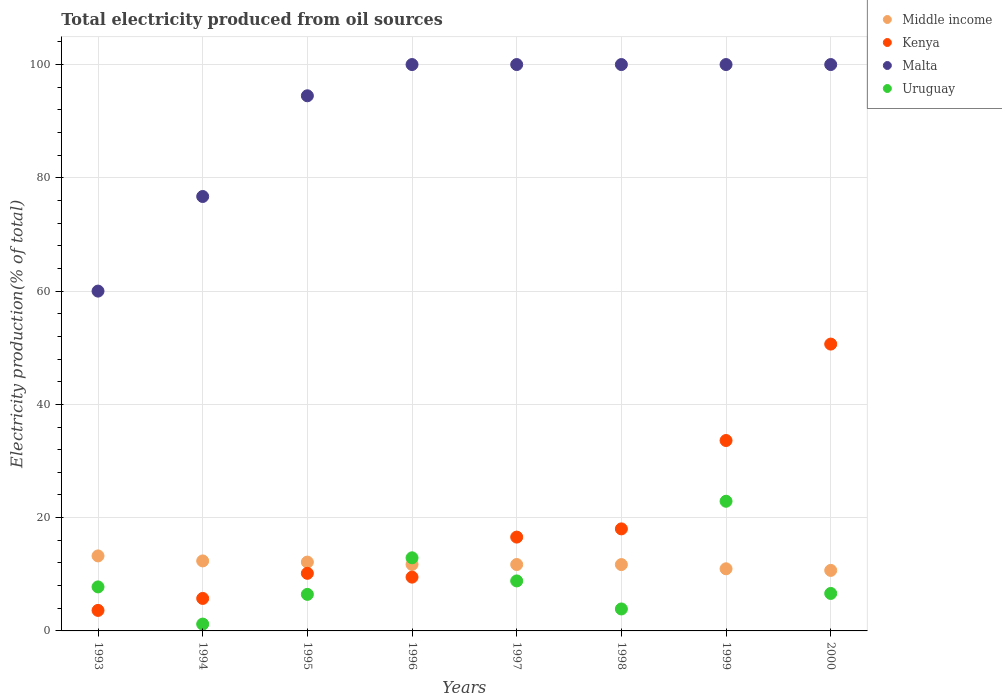How many different coloured dotlines are there?
Offer a very short reply. 4. Is the number of dotlines equal to the number of legend labels?
Offer a terse response. Yes. What is the total electricity produced in Middle income in 2000?
Your answer should be compact. 10.69. Across all years, what is the maximum total electricity produced in Malta?
Make the answer very short. 100. Across all years, what is the minimum total electricity produced in Kenya?
Ensure brevity in your answer.  3.62. In which year was the total electricity produced in Middle income maximum?
Your response must be concise. 1993. What is the total total electricity produced in Malta in the graph?
Make the answer very short. 731.19. What is the difference between the total electricity produced in Middle income in 1993 and that in 1997?
Give a very brief answer. 1.52. What is the difference between the total electricity produced in Malta in 1993 and the total electricity produced in Kenya in 1995?
Make the answer very short. 49.83. What is the average total electricity produced in Malta per year?
Provide a succinct answer. 91.4. In the year 1999, what is the difference between the total electricity produced in Malta and total electricity produced in Middle income?
Your response must be concise. 89.03. In how many years, is the total electricity produced in Uruguay greater than 80 %?
Offer a very short reply. 0. What is the ratio of the total electricity produced in Malta in 1993 to that in 1994?
Your response must be concise. 0.78. What is the difference between the highest and the second highest total electricity produced in Kenya?
Provide a short and direct response. 17.02. What is the difference between the highest and the lowest total electricity produced in Middle income?
Give a very brief answer. 2.56. Is the sum of the total electricity produced in Malta in 1995 and 1999 greater than the maximum total electricity produced in Middle income across all years?
Your answer should be compact. Yes. Is it the case that in every year, the sum of the total electricity produced in Malta and total electricity produced in Middle income  is greater than the sum of total electricity produced in Uruguay and total electricity produced in Kenya?
Your answer should be compact. Yes. Does the total electricity produced in Middle income monotonically increase over the years?
Give a very brief answer. No. Is the total electricity produced in Malta strictly greater than the total electricity produced in Middle income over the years?
Give a very brief answer. Yes. Is the total electricity produced in Uruguay strictly less than the total electricity produced in Middle income over the years?
Keep it short and to the point. No. Are the values on the major ticks of Y-axis written in scientific E-notation?
Give a very brief answer. No. Does the graph contain grids?
Make the answer very short. Yes. What is the title of the graph?
Your answer should be very brief. Total electricity produced from oil sources. Does "Sudan" appear as one of the legend labels in the graph?
Keep it short and to the point. No. What is the label or title of the Y-axis?
Provide a succinct answer. Electricity production(% of total). What is the Electricity production(% of total) in Middle income in 1993?
Provide a succinct answer. 13.24. What is the Electricity production(% of total) of Kenya in 1993?
Offer a terse response. 3.62. What is the Electricity production(% of total) in Uruguay in 1993?
Make the answer very short. 7.77. What is the Electricity production(% of total) of Middle income in 1994?
Your response must be concise. 12.36. What is the Electricity production(% of total) in Kenya in 1994?
Keep it short and to the point. 5.74. What is the Electricity production(% of total) in Malta in 1994?
Ensure brevity in your answer.  76.7. What is the Electricity production(% of total) in Uruguay in 1994?
Make the answer very short. 1.21. What is the Electricity production(% of total) in Middle income in 1995?
Make the answer very short. 12.15. What is the Electricity production(% of total) of Kenya in 1995?
Provide a succinct answer. 10.17. What is the Electricity production(% of total) of Malta in 1995?
Provide a succinct answer. 94.49. What is the Electricity production(% of total) in Uruguay in 1995?
Your answer should be very brief. 6.45. What is the Electricity production(% of total) of Middle income in 1996?
Offer a very short reply. 11.74. What is the Electricity production(% of total) in Kenya in 1996?
Give a very brief answer. 9.5. What is the Electricity production(% of total) of Malta in 1996?
Your response must be concise. 100. What is the Electricity production(% of total) in Uruguay in 1996?
Provide a succinct answer. 12.91. What is the Electricity production(% of total) in Middle income in 1997?
Keep it short and to the point. 11.73. What is the Electricity production(% of total) of Kenya in 1997?
Make the answer very short. 16.57. What is the Electricity production(% of total) of Malta in 1997?
Give a very brief answer. 100. What is the Electricity production(% of total) of Uruguay in 1997?
Ensure brevity in your answer.  8.83. What is the Electricity production(% of total) in Middle income in 1998?
Provide a succinct answer. 11.71. What is the Electricity production(% of total) of Kenya in 1998?
Give a very brief answer. 18.02. What is the Electricity production(% of total) in Uruguay in 1998?
Provide a short and direct response. 3.88. What is the Electricity production(% of total) in Middle income in 1999?
Keep it short and to the point. 10.97. What is the Electricity production(% of total) of Kenya in 1999?
Your answer should be very brief. 33.62. What is the Electricity production(% of total) in Malta in 1999?
Offer a terse response. 100. What is the Electricity production(% of total) of Uruguay in 1999?
Your answer should be very brief. 22.89. What is the Electricity production(% of total) of Middle income in 2000?
Your answer should be very brief. 10.69. What is the Electricity production(% of total) of Kenya in 2000?
Offer a terse response. 50.64. What is the Electricity production(% of total) of Uruguay in 2000?
Provide a succinct answer. 6.62. Across all years, what is the maximum Electricity production(% of total) of Middle income?
Your answer should be very brief. 13.24. Across all years, what is the maximum Electricity production(% of total) in Kenya?
Offer a terse response. 50.64. Across all years, what is the maximum Electricity production(% of total) of Uruguay?
Your answer should be compact. 22.89. Across all years, what is the minimum Electricity production(% of total) of Middle income?
Your answer should be very brief. 10.69. Across all years, what is the minimum Electricity production(% of total) of Kenya?
Provide a succinct answer. 3.62. Across all years, what is the minimum Electricity production(% of total) in Uruguay?
Provide a succinct answer. 1.21. What is the total Electricity production(% of total) in Middle income in the graph?
Give a very brief answer. 94.59. What is the total Electricity production(% of total) in Kenya in the graph?
Make the answer very short. 147.87. What is the total Electricity production(% of total) of Malta in the graph?
Your answer should be compact. 731.19. What is the total Electricity production(% of total) in Uruguay in the graph?
Offer a very short reply. 70.56. What is the difference between the Electricity production(% of total) of Middle income in 1993 and that in 1994?
Provide a succinct answer. 0.88. What is the difference between the Electricity production(% of total) in Kenya in 1993 and that in 1994?
Give a very brief answer. -2.11. What is the difference between the Electricity production(% of total) in Malta in 1993 and that in 1994?
Ensure brevity in your answer.  -16.7. What is the difference between the Electricity production(% of total) of Uruguay in 1993 and that in 1994?
Provide a short and direct response. 6.56. What is the difference between the Electricity production(% of total) of Middle income in 1993 and that in 1995?
Make the answer very short. 1.09. What is the difference between the Electricity production(% of total) of Kenya in 1993 and that in 1995?
Ensure brevity in your answer.  -6.55. What is the difference between the Electricity production(% of total) in Malta in 1993 and that in 1995?
Provide a short and direct response. -34.49. What is the difference between the Electricity production(% of total) in Uruguay in 1993 and that in 1995?
Ensure brevity in your answer.  1.32. What is the difference between the Electricity production(% of total) of Middle income in 1993 and that in 1996?
Your answer should be compact. 1.51. What is the difference between the Electricity production(% of total) in Kenya in 1993 and that in 1996?
Offer a very short reply. -5.87. What is the difference between the Electricity production(% of total) of Malta in 1993 and that in 1996?
Ensure brevity in your answer.  -40. What is the difference between the Electricity production(% of total) in Uruguay in 1993 and that in 1996?
Offer a terse response. -5.14. What is the difference between the Electricity production(% of total) of Middle income in 1993 and that in 1997?
Keep it short and to the point. 1.52. What is the difference between the Electricity production(% of total) of Kenya in 1993 and that in 1997?
Your answer should be compact. -12.94. What is the difference between the Electricity production(% of total) in Malta in 1993 and that in 1997?
Your answer should be compact. -40. What is the difference between the Electricity production(% of total) of Uruguay in 1993 and that in 1997?
Offer a very short reply. -1.06. What is the difference between the Electricity production(% of total) in Middle income in 1993 and that in 1998?
Offer a terse response. 1.53. What is the difference between the Electricity production(% of total) in Kenya in 1993 and that in 1998?
Offer a very short reply. -14.39. What is the difference between the Electricity production(% of total) of Uruguay in 1993 and that in 1998?
Provide a short and direct response. 3.89. What is the difference between the Electricity production(% of total) in Middle income in 1993 and that in 1999?
Give a very brief answer. 2.27. What is the difference between the Electricity production(% of total) of Kenya in 1993 and that in 1999?
Keep it short and to the point. -30. What is the difference between the Electricity production(% of total) in Uruguay in 1993 and that in 1999?
Your answer should be very brief. -15.12. What is the difference between the Electricity production(% of total) of Middle income in 1993 and that in 2000?
Provide a short and direct response. 2.56. What is the difference between the Electricity production(% of total) of Kenya in 1993 and that in 2000?
Offer a very short reply. -47.02. What is the difference between the Electricity production(% of total) in Uruguay in 1993 and that in 2000?
Make the answer very short. 1.16. What is the difference between the Electricity production(% of total) of Middle income in 1994 and that in 1995?
Give a very brief answer. 0.21. What is the difference between the Electricity production(% of total) of Kenya in 1994 and that in 1995?
Offer a terse response. -4.43. What is the difference between the Electricity production(% of total) in Malta in 1994 and that in 1995?
Your response must be concise. -17.78. What is the difference between the Electricity production(% of total) of Uruguay in 1994 and that in 1995?
Give a very brief answer. -5.25. What is the difference between the Electricity production(% of total) of Middle income in 1994 and that in 1996?
Offer a very short reply. 0.62. What is the difference between the Electricity production(% of total) of Kenya in 1994 and that in 1996?
Your answer should be very brief. -3.76. What is the difference between the Electricity production(% of total) in Malta in 1994 and that in 1996?
Offer a very short reply. -23.3. What is the difference between the Electricity production(% of total) in Uruguay in 1994 and that in 1996?
Provide a succinct answer. -11.7. What is the difference between the Electricity production(% of total) of Middle income in 1994 and that in 1997?
Provide a succinct answer. 0.63. What is the difference between the Electricity production(% of total) in Kenya in 1994 and that in 1997?
Ensure brevity in your answer.  -10.83. What is the difference between the Electricity production(% of total) of Malta in 1994 and that in 1997?
Ensure brevity in your answer.  -23.3. What is the difference between the Electricity production(% of total) in Uruguay in 1994 and that in 1997?
Provide a succinct answer. -7.62. What is the difference between the Electricity production(% of total) of Middle income in 1994 and that in 1998?
Give a very brief answer. 0.65. What is the difference between the Electricity production(% of total) in Kenya in 1994 and that in 1998?
Offer a terse response. -12.28. What is the difference between the Electricity production(% of total) in Malta in 1994 and that in 1998?
Offer a very short reply. -23.3. What is the difference between the Electricity production(% of total) of Uruguay in 1994 and that in 1998?
Give a very brief answer. -2.67. What is the difference between the Electricity production(% of total) of Middle income in 1994 and that in 1999?
Your answer should be very brief. 1.39. What is the difference between the Electricity production(% of total) of Kenya in 1994 and that in 1999?
Keep it short and to the point. -27.88. What is the difference between the Electricity production(% of total) in Malta in 1994 and that in 1999?
Your answer should be very brief. -23.3. What is the difference between the Electricity production(% of total) of Uruguay in 1994 and that in 1999?
Your response must be concise. -21.69. What is the difference between the Electricity production(% of total) in Middle income in 1994 and that in 2000?
Offer a very short reply. 1.67. What is the difference between the Electricity production(% of total) of Kenya in 1994 and that in 2000?
Your answer should be very brief. -44.91. What is the difference between the Electricity production(% of total) of Malta in 1994 and that in 2000?
Offer a very short reply. -23.3. What is the difference between the Electricity production(% of total) in Uruguay in 1994 and that in 2000?
Offer a terse response. -5.41. What is the difference between the Electricity production(% of total) of Middle income in 1995 and that in 1996?
Your answer should be compact. 0.42. What is the difference between the Electricity production(% of total) of Kenya in 1995 and that in 1996?
Your answer should be compact. 0.67. What is the difference between the Electricity production(% of total) in Malta in 1995 and that in 1996?
Provide a succinct answer. -5.51. What is the difference between the Electricity production(% of total) in Uruguay in 1995 and that in 1996?
Give a very brief answer. -6.46. What is the difference between the Electricity production(% of total) in Middle income in 1995 and that in 1997?
Give a very brief answer. 0.43. What is the difference between the Electricity production(% of total) of Kenya in 1995 and that in 1997?
Provide a succinct answer. -6.4. What is the difference between the Electricity production(% of total) of Malta in 1995 and that in 1997?
Provide a short and direct response. -5.51. What is the difference between the Electricity production(% of total) of Uruguay in 1995 and that in 1997?
Ensure brevity in your answer.  -2.37. What is the difference between the Electricity production(% of total) of Middle income in 1995 and that in 1998?
Your answer should be compact. 0.44. What is the difference between the Electricity production(% of total) in Kenya in 1995 and that in 1998?
Your answer should be very brief. -7.85. What is the difference between the Electricity production(% of total) in Malta in 1995 and that in 1998?
Ensure brevity in your answer.  -5.51. What is the difference between the Electricity production(% of total) of Uruguay in 1995 and that in 1998?
Keep it short and to the point. 2.58. What is the difference between the Electricity production(% of total) of Middle income in 1995 and that in 1999?
Offer a terse response. 1.18. What is the difference between the Electricity production(% of total) of Kenya in 1995 and that in 1999?
Your answer should be compact. -23.45. What is the difference between the Electricity production(% of total) in Malta in 1995 and that in 1999?
Your answer should be compact. -5.51. What is the difference between the Electricity production(% of total) in Uruguay in 1995 and that in 1999?
Offer a very short reply. -16.44. What is the difference between the Electricity production(% of total) in Middle income in 1995 and that in 2000?
Provide a succinct answer. 1.47. What is the difference between the Electricity production(% of total) in Kenya in 1995 and that in 2000?
Your answer should be very brief. -40.48. What is the difference between the Electricity production(% of total) of Malta in 1995 and that in 2000?
Provide a succinct answer. -5.51. What is the difference between the Electricity production(% of total) in Uruguay in 1995 and that in 2000?
Provide a short and direct response. -0.16. What is the difference between the Electricity production(% of total) of Middle income in 1996 and that in 1997?
Make the answer very short. 0.01. What is the difference between the Electricity production(% of total) of Kenya in 1996 and that in 1997?
Your answer should be very brief. -7.07. What is the difference between the Electricity production(% of total) of Uruguay in 1996 and that in 1997?
Offer a terse response. 4.08. What is the difference between the Electricity production(% of total) of Middle income in 1996 and that in 1998?
Provide a succinct answer. 0.02. What is the difference between the Electricity production(% of total) in Kenya in 1996 and that in 1998?
Offer a very short reply. -8.52. What is the difference between the Electricity production(% of total) in Malta in 1996 and that in 1998?
Provide a short and direct response. 0. What is the difference between the Electricity production(% of total) in Uruguay in 1996 and that in 1998?
Your answer should be compact. 9.03. What is the difference between the Electricity production(% of total) of Middle income in 1996 and that in 1999?
Make the answer very short. 0.76. What is the difference between the Electricity production(% of total) of Kenya in 1996 and that in 1999?
Provide a short and direct response. -24.12. What is the difference between the Electricity production(% of total) in Uruguay in 1996 and that in 1999?
Offer a very short reply. -9.99. What is the difference between the Electricity production(% of total) in Middle income in 1996 and that in 2000?
Give a very brief answer. 1.05. What is the difference between the Electricity production(% of total) in Kenya in 1996 and that in 2000?
Keep it short and to the point. -41.15. What is the difference between the Electricity production(% of total) of Malta in 1996 and that in 2000?
Your response must be concise. 0. What is the difference between the Electricity production(% of total) of Uruguay in 1996 and that in 2000?
Your answer should be very brief. 6.29. What is the difference between the Electricity production(% of total) of Middle income in 1997 and that in 1998?
Offer a terse response. 0.01. What is the difference between the Electricity production(% of total) in Kenya in 1997 and that in 1998?
Offer a very short reply. -1.45. What is the difference between the Electricity production(% of total) in Uruguay in 1997 and that in 1998?
Your response must be concise. 4.95. What is the difference between the Electricity production(% of total) in Middle income in 1997 and that in 1999?
Make the answer very short. 0.75. What is the difference between the Electricity production(% of total) of Kenya in 1997 and that in 1999?
Your answer should be compact. -17.05. What is the difference between the Electricity production(% of total) in Malta in 1997 and that in 1999?
Your answer should be compact. 0. What is the difference between the Electricity production(% of total) in Uruguay in 1997 and that in 1999?
Ensure brevity in your answer.  -14.07. What is the difference between the Electricity production(% of total) in Middle income in 1997 and that in 2000?
Offer a terse response. 1.04. What is the difference between the Electricity production(% of total) in Kenya in 1997 and that in 2000?
Provide a succinct answer. -34.08. What is the difference between the Electricity production(% of total) of Malta in 1997 and that in 2000?
Your response must be concise. 0. What is the difference between the Electricity production(% of total) in Uruguay in 1997 and that in 2000?
Ensure brevity in your answer.  2.21. What is the difference between the Electricity production(% of total) in Middle income in 1998 and that in 1999?
Your answer should be compact. 0.74. What is the difference between the Electricity production(% of total) of Kenya in 1998 and that in 1999?
Make the answer very short. -15.6. What is the difference between the Electricity production(% of total) of Malta in 1998 and that in 1999?
Your answer should be very brief. 0. What is the difference between the Electricity production(% of total) of Uruguay in 1998 and that in 1999?
Make the answer very short. -19.02. What is the difference between the Electricity production(% of total) of Middle income in 1998 and that in 2000?
Give a very brief answer. 1.03. What is the difference between the Electricity production(% of total) of Kenya in 1998 and that in 2000?
Offer a very short reply. -32.63. What is the difference between the Electricity production(% of total) of Uruguay in 1998 and that in 2000?
Your answer should be compact. -2.74. What is the difference between the Electricity production(% of total) of Middle income in 1999 and that in 2000?
Give a very brief answer. 0.28. What is the difference between the Electricity production(% of total) in Kenya in 1999 and that in 2000?
Give a very brief answer. -17.02. What is the difference between the Electricity production(% of total) of Malta in 1999 and that in 2000?
Your answer should be compact. 0. What is the difference between the Electricity production(% of total) in Uruguay in 1999 and that in 2000?
Make the answer very short. 16.28. What is the difference between the Electricity production(% of total) of Middle income in 1993 and the Electricity production(% of total) of Kenya in 1994?
Keep it short and to the point. 7.51. What is the difference between the Electricity production(% of total) of Middle income in 1993 and the Electricity production(% of total) of Malta in 1994?
Offer a very short reply. -63.46. What is the difference between the Electricity production(% of total) of Middle income in 1993 and the Electricity production(% of total) of Uruguay in 1994?
Ensure brevity in your answer.  12.04. What is the difference between the Electricity production(% of total) in Kenya in 1993 and the Electricity production(% of total) in Malta in 1994?
Your answer should be very brief. -73.08. What is the difference between the Electricity production(% of total) of Kenya in 1993 and the Electricity production(% of total) of Uruguay in 1994?
Offer a terse response. 2.42. What is the difference between the Electricity production(% of total) of Malta in 1993 and the Electricity production(% of total) of Uruguay in 1994?
Ensure brevity in your answer.  58.79. What is the difference between the Electricity production(% of total) of Middle income in 1993 and the Electricity production(% of total) of Kenya in 1995?
Keep it short and to the point. 3.08. What is the difference between the Electricity production(% of total) in Middle income in 1993 and the Electricity production(% of total) in Malta in 1995?
Offer a very short reply. -81.24. What is the difference between the Electricity production(% of total) in Middle income in 1993 and the Electricity production(% of total) in Uruguay in 1995?
Provide a short and direct response. 6.79. What is the difference between the Electricity production(% of total) of Kenya in 1993 and the Electricity production(% of total) of Malta in 1995?
Make the answer very short. -90.86. What is the difference between the Electricity production(% of total) in Kenya in 1993 and the Electricity production(% of total) in Uruguay in 1995?
Your answer should be compact. -2.83. What is the difference between the Electricity production(% of total) of Malta in 1993 and the Electricity production(% of total) of Uruguay in 1995?
Offer a very short reply. 53.55. What is the difference between the Electricity production(% of total) of Middle income in 1993 and the Electricity production(% of total) of Kenya in 1996?
Your answer should be compact. 3.75. What is the difference between the Electricity production(% of total) in Middle income in 1993 and the Electricity production(% of total) in Malta in 1996?
Make the answer very short. -86.76. What is the difference between the Electricity production(% of total) in Middle income in 1993 and the Electricity production(% of total) in Uruguay in 1996?
Provide a succinct answer. 0.34. What is the difference between the Electricity production(% of total) of Kenya in 1993 and the Electricity production(% of total) of Malta in 1996?
Provide a succinct answer. -96.38. What is the difference between the Electricity production(% of total) in Kenya in 1993 and the Electricity production(% of total) in Uruguay in 1996?
Make the answer very short. -9.29. What is the difference between the Electricity production(% of total) in Malta in 1993 and the Electricity production(% of total) in Uruguay in 1996?
Provide a succinct answer. 47.09. What is the difference between the Electricity production(% of total) in Middle income in 1993 and the Electricity production(% of total) in Kenya in 1997?
Offer a terse response. -3.32. What is the difference between the Electricity production(% of total) in Middle income in 1993 and the Electricity production(% of total) in Malta in 1997?
Your answer should be very brief. -86.76. What is the difference between the Electricity production(% of total) of Middle income in 1993 and the Electricity production(% of total) of Uruguay in 1997?
Keep it short and to the point. 4.42. What is the difference between the Electricity production(% of total) of Kenya in 1993 and the Electricity production(% of total) of Malta in 1997?
Your answer should be very brief. -96.38. What is the difference between the Electricity production(% of total) of Kenya in 1993 and the Electricity production(% of total) of Uruguay in 1997?
Ensure brevity in your answer.  -5.2. What is the difference between the Electricity production(% of total) of Malta in 1993 and the Electricity production(% of total) of Uruguay in 1997?
Your answer should be very brief. 51.17. What is the difference between the Electricity production(% of total) in Middle income in 1993 and the Electricity production(% of total) in Kenya in 1998?
Your answer should be compact. -4.77. What is the difference between the Electricity production(% of total) in Middle income in 1993 and the Electricity production(% of total) in Malta in 1998?
Provide a succinct answer. -86.76. What is the difference between the Electricity production(% of total) in Middle income in 1993 and the Electricity production(% of total) in Uruguay in 1998?
Offer a very short reply. 9.37. What is the difference between the Electricity production(% of total) of Kenya in 1993 and the Electricity production(% of total) of Malta in 1998?
Provide a short and direct response. -96.38. What is the difference between the Electricity production(% of total) of Kenya in 1993 and the Electricity production(% of total) of Uruguay in 1998?
Make the answer very short. -0.25. What is the difference between the Electricity production(% of total) in Malta in 1993 and the Electricity production(% of total) in Uruguay in 1998?
Give a very brief answer. 56.12. What is the difference between the Electricity production(% of total) of Middle income in 1993 and the Electricity production(% of total) of Kenya in 1999?
Your answer should be compact. -20.38. What is the difference between the Electricity production(% of total) in Middle income in 1993 and the Electricity production(% of total) in Malta in 1999?
Offer a terse response. -86.76. What is the difference between the Electricity production(% of total) of Middle income in 1993 and the Electricity production(% of total) of Uruguay in 1999?
Ensure brevity in your answer.  -9.65. What is the difference between the Electricity production(% of total) of Kenya in 1993 and the Electricity production(% of total) of Malta in 1999?
Make the answer very short. -96.38. What is the difference between the Electricity production(% of total) in Kenya in 1993 and the Electricity production(% of total) in Uruguay in 1999?
Ensure brevity in your answer.  -19.27. What is the difference between the Electricity production(% of total) of Malta in 1993 and the Electricity production(% of total) of Uruguay in 1999?
Ensure brevity in your answer.  37.11. What is the difference between the Electricity production(% of total) of Middle income in 1993 and the Electricity production(% of total) of Kenya in 2000?
Ensure brevity in your answer.  -37.4. What is the difference between the Electricity production(% of total) in Middle income in 1993 and the Electricity production(% of total) in Malta in 2000?
Your answer should be very brief. -86.76. What is the difference between the Electricity production(% of total) in Middle income in 1993 and the Electricity production(% of total) in Uruguay in 2000?
Your answer should be compact. 6.63. What is the difference between the Electricity production(% of total) of Kenya in 1993 and the Electricity production(% of total) of Malta in 2000?
Offer a terse response. -96.38. What is the difference between the Electricity production(% of total) of Kenya in 1993 and the Electricity production(% of total) of Uruguay in 2000?
Provide a succinct answer. -2.99. What is the difference between the Electricity production(% of total) in Malta in 1993 and the Electricity production(% of total) in Uruguay in 2000?
Your answer should be compact. 53.38. What is the difference between the Electricity production(% of total) of Middle income in 1994 and the Electricity production(% of total) of Kenya in 1995?
Provide a succinct answer. 2.19. What is the difference between the Electricity production(% of total) of Middle income in 1994 and the Electricity production(% of total) of Malta in 1995?
Provide a succinct answer. -82.13. What is the difference between the Electricity production(% of total) in Middle income in 1994 and the Electricity production(% of total) in Uruguay in 1995?
Your response must be concise. 5.91. What is the difference between the Electricity production(% of total) in Kenya in 1994 and the Electricity production(% of total) in Malta in 1995?
Your response must be concise. -88.75. What is the difference between the Electricity production(% of total) of Kenya in 1994 and the Electricity production(% of total) of Uruguay in 1995?
Make the answer very short. -0.72. What is the difference between the Electricity production(% of total) in Malta in 1994 and the Electricity production(% of total) in Uruguay in 1995?
Ensure brevity in your answer.  70.25. What is the difference between the Electricity production(% of total) of Middle income in 1994 and the Electricity production(% of total) of Kenya in 1996?
Give a very brief answer. 2.86. What is the difference between the Electricity production(% of total) in Middle income in 1994 and the Electricity production(% of total) in Malta in 1996?
Offer a terse response. -87.64. What is the difference between the Electricity production(% of total) in Middle income in 1994 and the Electricity production(% of total) in Uruguay in 1996?
Keep it short and to the point. -0.55. What is the difference between the Electricity production(% of total) of Kenya in 1994 and the Electricity production(% of total) of Malta in 1996?
Provide a succinct answer. -94.26. What is the difference between the Electricity production(% of total) in Kenya in 1994 and the Electricity production(% of total) in Uruguay in 1996?
Make the answer very short. -7.17. What is the difference between the Electricity production(% of total) in Malta in 1994 and the Electricity production(% of total) in Uruguay in 1996?
Your answer should be compact. 63.79. What is the difference between the Electricity production(% of total) of Middle income in 1994 and the Electricity production(% of total) of Kenya in 1997?
Offer a terse response. -4.21. What is the difference between the Electricity production(% of total) in Middle income in 1994 and the Electricity production(% of total) in Malta in 1997?
Provide a short and direct response. -87.64. What is the difference between the Electricity production(% of total) of Middle income in 1994 and the Electricity production(% of total) of Uruguay in 1997?
Offer a terse response. 3.53. What is the difference between the Electricity production(% of total) in Kenya in 1994 and the Electricity production(% of total) in Malta in 1997?
Your answer should be compact. -94.26. What is the difference between the Electricity production(% of total) of Kenya in 1994 and the Electricity production(% of total) of Uruguay in 1997?
Offer a terse response. -3.09. What is the difference between the Electricity production(% of total) in Malta in 1994 and the Electricity production(% of total) in Uruguay in 1997?
Make the answer very short. 67.88. What is the difference between the Electricity production(% of total) in Middle income in 1994 and the Electricity production(% of total) in Kenya in 1998?
Give a very brief answer. -5.66. What is the difference between the Electricity production(% of total) in Middle income in 1994 and the Electricity production(% of total) in Malta in 1998?
Offer a terse response. -87.64. What is the difference between the Electricity production(% of total) in Middle income in 1994 and the Electricity production(% of total) in Uruguay in 1998?
Make the answer very short. 8.48. What is the difference between the Electricity production(% of total) in Kenya in 1994 and the Electricity production(% of total) in Malta in 1998?
Provide a short and direct response. -94.26. What is the difference between the Electricity production(% of total) in Kenya in 1994 and the Electricity production(% of total) in Uruguay in 1998?
Provide a short and direct response. 1.86. What is the difference between the Electricity production(% of total) in Malta in 1994 and the Electricity production(% of total) in Uruguay in 1998?
Your response must be concise. 72.83. What is the difference between the Electricity production(% of total) of Middle income in 1994 and the Electricity production(% of total) of Kenya in 1999?
Provide a short and direct response. -21.26. What is the difference between the Electricity production(% of total) of Middle income in 1994 and the Electricity production(% of total) of Malta in 1999?
Give a very brief answer. -87.64. What is the difference between the Electricity production(% of total) of Middle income in 1994 and the Electricity production(% of total) of Uruguay in 1999?
Your answer should be compact. -10.53. What is the difference between the Electricity production(% of total) in Kenya in 1994 and the Electricity production(% of total) in Malta in 1999?
Provide a short and direct response. -94.26. What is the difference between the Electricity production(% of total) in Kenya in 1994 and the Electricity production(% of total) in Uruguay in 1999?
Offer a terse response. -17.16. What is the difference between the Electricity production(% of total) of Malta in 1994 and the Electricity production(% of total) of Uruguay in 1999?
Provide a succinct answer. 53.81. What is the difference between the Electricity production(% of total) of Middle income in 1994 and the Electricity production(% of total) of Kenya in 2000?
Your response must be concise. -38.28. What is the difference between the Electricity production(% of total) in Middle income in 1994 and the Electricity production(% of total) in Malta in 2000?
Offer a very short reply. -87.64. What is the difference between the Electricity production(% of total) in Middle income in 1994 and the Electricity production(% of total) in Uruguay in 2000?
Keep it short and to the point. 5.74. What is the difference between the Electricity production(% of total) in Kenya in 1994 and the Electricity production(% of total) in Malta in 2000?
Your response must be concise. -94.26. What is the difference between the Electricity production(% of total) of Kenya in 1994 and the Electricity production(% of total) of Uruguay in 2000?
Give a very brief answer. -0.88. What is the difference between the Electricity production(% of total) of Malta in 1994 and the Electricity production(% of total) of Uruguay in 2000?
Your answer should be compact. 70.09. What is the difference between the Electricity production(% of total) of Middle income in 1995 and the Electricity production(% of total) of Kenya in 1996?
Keep it short and to the point. 2.66. What is the difference between the Electricity production(% of total) in Middle income in 1995 and the Electricity production(% of total) in Malta in 1996?
Your answer should be very brief. -87.85. What is the difference between the Electricity production(% of total) in Middle income in 1995 and the Electricity production(% of total) in Uruguay in 1996?
Keep it short and to the point. -0.75. What is the difference between the Electricity production(% of total) in Kenya in 1995 and the Electricity production(% of total) in Malta in 1996?
Keep it short and to the point. -89.83. What is the difference between the Electricity production(% of total) of Kenya in 1995 and the Electricity production(% of total) of Uruguay in 1996?
Give a very brief answer. -2.74. What is the difference between the Electricity production(% of total) of Malta in 1995 and the Electricity production(% of total) of Uruguay in 1996?
Provide a succinct answer. 81.58. What is the difference between the Electricity production(% of total) of Middle income in 1995 and the Electricity production(% of total) of Kenya in 1997?
Give a very brief answer. -4.41. What is the difference between the Electricity production(% of total) in Middle income in 1995 and the Electricity production(% of total) in Malta in 1997?
Give a very brief answer. -87.85. What is the difference between the Electricity production(% of total) in Middle income in 1995 and the Electricity production(% of total) in Uruguay in 1997?
Your answer should be very brief. 3.33. What is the difference between the Electricity production(% of total) in Kenya in 1995 and the Electricity production(% of total) in Malta in 1997?
Provide a short and direct response. -89.83. What is the difference between the Electricity production(% of total) in Kenya in 1995 and the Electricity production(% of total) in Uruguay in 1997?
Give a very brief answer. 1.34. What is the difference between the Electricity production(% of total) in Malta in 1995 and the Electricity production(% of total) in Uruguay in 1997?
Offer a very short reply. 85.66. What is the difference between the Electricity production(% of total) of Middle income in 1995 and the Electricity production(% of total) of Kenya in 1998?
Your answer should be compact. -5.86. What is the difference between the Electricity production(% of total) of Middle income in 1995 and the Electricity production(% of total) of Malta in 1998?
Make the answer very short. -87.85. What is the difference between the Electricity production(% of total) of Middle income in 1995 and the Electricity production(% of total) of Uruguay in 1998?
Make the answer very short. 8.28. What is the difference between the Electricity production(% of total) in Kenya in 1995 and the Electricity production(% of total) in Malta in 1998?
Keep it short and to the point. -89.83. What is the difference between the Electricity production(% of total) in Kenya in 1995 and the Electricity production(% of total) in Uruguay in 1998?
Keep it short and to the point. 6.29. What is the difference between the Electricity production(% of total) of Malta in 1995 and the Electricity production(% of total) of Uruguay in 1998?
Ensure brevity in your answer.  90.61. What is the difference between the Electricity production(% of total) in Middle income in 1995 and the Electricity production(% of total) in Kenya in 1999?
Your answer should be compact. -21.47. What is the difference between the Electricity production(% of total) of Middle income in 1995 and the Electricity production(% of total) of Malta in 1999?
Provide a short and direct response. -87.85. What is the difference between the Electricity production(% of total) in Middle income in 1995 and the Electricity production(% of total) in Uruguay in 1999?
Make the answer very short. -10.74. What is the difference between the Electricity production(% of total) in Kenya in 1995 and the Electricity production(% of total) in Malta in 1999?
Give a very brief answer. -89.83. What is the difference between the Electricity production(% of total) in Kenya in 1995 and the Electricity production(% of total) in Uruguay in 1999?
Make the answer very short. -12.73. What is the difference between the Electricity production(% of total) in Malta in 1995 and the Electricity production(% of total) in Uruguay in 1999?
Your answer should be compact. 71.59. What is the difference between the Electricity production(% of total) of Middle income in 1995 and the Electricity production(% of total) of Kenya in 2000?
Ensure brevity in your answer.  -38.49. What is the difference between the Electricity production(% of total) of Middle income in 1995 and the Electricity production(% of total) of Malta in 2000?
Your response must be concise. -87.85. What is the difference between the Electricity production(% of total) of Middle income in 1995 and the Electricity production(% of total) of Uruguay in 2000?
Make the answer very short. 5.54. What is the difference between the Electricity production(% of total) in Kenya in 1995 and the Electricity production(% of total) in Malta in 2000?
Provide a short and direct response. -89.83. What is the difference between the Electricity production(% of total) of Kenya in 1995 and the Electricity production(% of total) of Uruguay in 2000?
Your answer should be compact. 3.55. What is the difference between the Electricity production(% of total) in Malta in 1995 and the Electricity production(% of total) in Uruguay in 2000?
Your answer should be compact. 87.87. What is the difference between the Electricity production(% of total) of Middle income in 1996 and the Electricity production(% of total) of Kenya in 1997?
Your response must be concise. -4.83. What is the difference between the Electricity production(% of total) in Middle income in 1996 and the Electricity production(% of total) in Malta in 1997?
Your answer should be very brief. -88.26. What is the difference between the Electricity production(% of total) of Middle income in 1996 and the Electricity production(% of total) of Uruguay in 1997?
Provide a succinct answer. 2.91. What is the difference between the Electricity production(% of total) of Kenya in 1996 and the Electricity production(% of total) of Malta in 1997?
Give a very brief answer. -90.5. What is the difference between the Electricity production(% of total) in Kenya in 1996 and the Electricity production(% of total) in Uruguay in 1997?
Your answer should be very brief. 0.67. What is the difference between the Electricity production(% of total) in Malta in 1996 and the Electricity production(% of total) in Uruguay in 1997?
Keep it short and to the point. 91.17. What is the difference between the Electricity production(% of total) of Middle income in 1996 and the Electricity production(% of total) of Kenya in 1998?
Ensure brevity in your answer.  -6.28. What is the difference between the Electricity production(% of total) of Middle income in 1996 and the Electricity production(% of total) of Malta in 1998?
Your response must be concise. -88.26. What is the difference between the Electricity production(% of total) in Middle income in 1996 and the Electricity production(% of total) in Uruguay in 1998?
Your response must be concise. 7.86. What is the difference between the Electricity production(% of total) of Kenya in 1996 and the Electricity production(% of total) of Malta in 1998?
Ensure brevity in your answer.  -90.5. What is the difference between the Electricity production(% of total) in Kenya in 1996 and the Electricity production(% of total) in Uruguay in 1998?
Your answer should be very brief. 5.62. What is the difference between the Electricity production(% of total) in Malta in 1996 and the Electricity production(% of total) in Uruguay in 1998?
Give a very brief answer. 96.12. What is the difference between the Electricity production(% of total) of Middle income in 1996 and the Electricity production(% of total) of Kenya in 1999?
Your answer should be very brief. -21.88. What is the difference between the Electricity production(% of total) of Middle income in 1996 and the Electricity production(% of total) of Malta in 1999?
Give a very brief answer. -88.26. What is the difference between the Electricity production(% of total) of Middle income in 1996 and the Electricity production(% of total) of Uruguay in 1999?
Give a very brief answer. -11.16. What is the difference between the Electricity production(% of total) of Kenya in 1996 and the Electricity production(% of total) of Malta in 1999?
Your answer should be compact. -90.5. What is the difference between the Electricity production(% of total) in Kenya in 1996 and the Electricity production(% of total) in Uruguay in 1999?
Provide a succinct answer. -13.4. What is the difference between the Electricity production(% of total) of Malta in 1996 and the Electricity production(% of total) of Uruguay in 1999?
Ensure brevity in your answer.  77.11. What is the difference between the Electricity production(% of total) in Middle income in 1996 and the Electricity production(% of total) in Kenya in 2000?
Make the answer very short. -38.91. What is the difference between the Electricity production(% of total) of Middle income in 1996 and the Electricity production(% of total) of Malta in 2000?
Your answer should be compact. -88.26. What is the difference between the Electricity production(% of total) in Middle income in 1996 and the Electricity production(% of total) in Uruguay in 2000?
Offer a terse response. 5.12. What is the difference between the Electricity production(% of total) in Kenya in 1996 and the Electricity production(% of total) in Malta in 2000?
Your response must be concise. -90.5. What is the difference between the Electricity production(% of total) in Kenya in 1996 and the Electricity production(% of total) in Uruguay in 2000?
Give a very brief answer. 2.88. What is the difference between the Electricity production(% of total) in Malta in 1996 and the Electricity production(% of total) in Uruguay in 2000?
Make the answer very short. 93.38. What is the difference between the Electricity production(% of total) in Middle income in 1997 and the Electricity production(% of total) in Kenya in 1998?
Provide a succinct answer. -6.29. What is the difference between the Electricity production(% of total) of Middle income in 1997 and the Electricity production(% of total) of Malta in 1998?
Keep it short and to the point. -88.28. What is the difference between the Electricity production(% of total) of Middle income in 1997 and the Electricity production(% of total) of Uruguay in 1998?
Keep it short and to the point. 7.85. What is the difference between the Electricity production(% of total) in Kenya in 1997 and the Electricity production(% of total) in Malta in 1998?
Provide a short and direct response. -83.43. What is the difference between the Electricity production(% of total) in Kenya in 1997 and the Electricity production(% of total) in Uruguay in 1998?
Provide a succinct answer. 12.69. What is the difference between the Electricity production(% of total) of Malta in 1997 and the Electricity production(% of total) of Uruguay in 1998?
Your response must be concise. 96.12. What is the difference between the Electricity production(% of total) in Middle income in 1997 and the Electricity production(% of total) in Kenya in 1999?
Keep it short and to the point. -21.89. What is the difference between the Electricity production(% of total) of Middle income in 1997 and the Electricity production(% of total) of Malta in 1999?
Your answer should be very brief. -88.28. What is the difference between the Electricity production(% of total) of Middle income in 1997 and the Electricity production(% of total) of Uruguay in 1999?
Your response must be concise. -11.17. What is the difference between the Electricity production(% of total) of Kenya in 1997 and the Electricity production(% of total) of Malta in 1999?
Offer a terse response. -83.43. What is the difference between the Electricity production(% of total) in Kenya in 1997 and the Electricity production(% of total) in Uruguay in 1999?
Your answer should be very brief. -6.33. What is the difference between the Electricity production(% of total) in Malta in 1997 and the Electricity production(% of total) in Uruguay in 1999?
Your response must be concise. 77.11. What is the difference between the Electricity production(% of total) in Middle income in 1997 and the Electricity production(% of total) in Kenya in 2000?
Offer a very short reply. -38.92. What is the difference between the Electricity production(% of total) in Middle income in 1997 and the Electricity production(% of total) in Malta in 2000?
Your answer should be very brief. -88.28. What is the difference between the Electricity production(% of total) in Middle income in 1997 and the Electricity production(% of total) in Uruguay in 2000?
Your answer should be compact. 5.11. What is the difference between the Electricity production(% of total) of Kenya in 1997 and the Electricity production(% of total) of Malta in 2000?
Provide a short and direct response. -83.43. What is the difference between the Electricity production(% of total) of Kenya in 1997 and the Electricity production(% of total) of Uruguay in 2000?
Your answer should be compact. 9.95. What is the difference between the Electricity production(% of total) in Malta in 1997 and the Electricity production(% of total) in Uruguay in 2000?
Provide a succinct answer. 93.38. What is the difference between the Electricity production(% of total) of Middle income in 1998 and the Electricity production(% of total) of Kenya in 1999?
Make the answer very short. -21.91. What is the difference between the Electricity production(% of total) of Middle income in 1998 and the Electricity production(% of total) of Malta in 1999?
Your answer should be compact. -88.29. What is the difference between the Electricity production(% of total) of Middle income in 1998 and the Electricity production(% of total) of Uruguay in 1999?
Provide a succinct answer. -11.18. What is the difference between the Electricity production(% of total) in Kenya in 1998 and the Electricity production(% of total) in Malta in 1999?
Keep it short and to the point. -81.98. What is the difference between the Electricity production(% of total) of Kenya in 1998 and the Electricity production(% of total) of Uruguay in 1999?
Offer a very short reply. -4.88. What is the difference between the Electricity production(% of total) of Malta in 1998 and the Electricity production(% of total) of Uruguay in 1999?
Ensure brevity in your answer.  77.11. What is the difference between the Electricity production(% of total) of Middle income in 1998 and the Electricity production(% of total) of Kenya in 2000?
Offer a very short reply. -38.93. What is the difference between the Electricity production(% of total) of Middle income in 1998 and the Electricity production(% of total) of Malta in 2000?
Your answer should be compact. -88.29. What is the difference between the Electricity production(% of total) of Middle income in 1998 and the Electricity production(% of total) of Uruguay in 2000?
Give a very brief answer. 5.1. What is the difference between the Electricity production(% of total) of Kenya in 1998 and the Electricity production(% of total) of Malta in 2000?
Your answer should be compact. -81.98. What is the difference between the Electricity production(% of total) in Kenya in 1998 and the Electricity production(% of total) in Uruguay in 2000?
Your answer should be very brief. 11.4. What is the difference between the Electricity production(% of total) of Malta in 1998 and the Electricity production(% of total) of Uruguay in 2000?
Give a very brief answer. 93.38. What is the difference between the Electricity production(% of total) in Middle income in 1999 and the Electricity production(% of total) in Kenya in 2000?
Offer a very short reply. -39.67. What is the difference between the Electricity production(% of total) of Middle income in 1999 and the Electricity production(% of total) of Malta in 2000?
Your response must be concise. -89.03. What is the difference between the Electricity production(% of total) in Middle income in 1999 and the Electricity production(% of total) in Uruguay in 2000?
Your answer should be very brief. 4.35. What is the difference between the Electricity production(% of total) of Kenya in 1999 and the Electricity production(% of total) of Malta in 2000?
Your answer should be compact. -66.38. What is the difference between the Electricity production(% of total) in Kenya in 1999 and the Electricity production(% of total) in Uruguay in 2000?
Provide a short and direct response. 27. What is the difference between the Electricity production(% of total) of Malta in 1999 and the Electricity production(% of total) of Uruguay in 2000?
Keep it short and to the point. 93.38. What is the average Electricity production(% of total) of Middle income per year?
Keep it short and to the point. 11.82. What is the average Electricity production(% of total) of Kenya per year?
Provide a short and direct response. 18.48. What is the average Electricity production(% of total) in Malta per year?
Give a very brief answer. 91.4. What is the average Electricity production(% of total) in Uruguay per year?
Your response must be concise. 8.82. In the year 1993, what is the difference between the Electricity production(% of total) of Middle income and Electricity production(% of total) of Kenya?
Your response must be concise. 9.62. In the year 1993, what is the difference between the Electricity production(% of total) of Middle income and Electricity production(% of total) of Malta?
Offer a very short reply. -46.76. In the year 1993, what is the difference between the Electricity production(% of total) of Middle income and Electricity production(% of total) of Uruguay?
Provide a short and direct response. 5.47. In the year 1993, what is the difference between the Electricity production(% of total) of Kenya and Electricity production(% of total) of Malta?
Provide a short and direct response. -56.38. In the year 1993, what is the difference between the Electricity production(% of total) of Kenya and Electricity production(% of total) of Uruguay?
Make the answer very short. -4.15. In the year 1993, what is the difference between the Electricity production(% of total) in Malta and Electricity production(% of total) in Uruguay?
Provide a succinct answer. 52.23. In the year 1994, what is the difference between the Electricity production(% of total) in Middle income and Electricity production(% of total) in Kenya?
Your response must be concise. 6.62. In the year 1994, what is the difference between the Electricity production(% of total) in Middle income and Electricity production(% of total) in Malta?
Keep it short and to the point. -64.34. In the year 1994, what is the difference between the Electricity production(% of total) in Middle income and Electricity production(% of total) in Uruguay?
Offer a very short reply. 11.15. In the year 1994, what is the difference between the Electricity production(% of total) of Kenya and Electricity production(% of total) of Malta?
Offer a very short reply. -70.97. In the year 1994, what is the difference between the Electricity production(% of total) of Kenya and Electricity production(% of total) of Uruguay?
Your answer should be very brief. 4.53. In the year 1994, what is the difference between the Electricity production(% of total) of Malta and Electricity production(% of total) of Uruguay?
Your answer should be very brief. 75.5. In the year 1995, what is the difference between the Electricity production(% of total) of Middle income and Electricity production(% of total) of Kenya?
Offer a terse response. 1.99. In the year 1995, what is the difference between the Electricity production(% of total) of Middle income and Electricity production(% of total) of Malta?
Provide a succinct answer. -82.33. In the year 1995, what is the difference between the Electricity production(% of total) of Middle income and Electricity production(% of total) of Uruguay?
Your response must be concise. 5.7. In the year 1995, what is the difference between the Electricity production(% of total) in Kenya and Electricity production(% of total) in Malta?
Your answer should be compact. -84.32. In the year 1995, what is the difference between the Electricity production(% of total) of Kenya and Electricity production(% of total) of Uruguay?
Make the answer very short. 3.72. In the year 1995, what is the difference between the Electricity production(% of total) in Malta and Electricity production(% of total) in Uruguay?
Provide a succinct answer. 88.03. In the year 1996, what is the difference between the Electricity production(% of total) of Middle income and Electricity production(% of total) of Kenya?
Your answer should be compact. 2.24. In the year 1996, what is the difference between the Electricity production(% of total) in Middle income and Electricity production(% of total) in Malta?
Ensure brevity in your answer.  -88.26. In the year 1996, what is the difference between the Electricity production(% of total) in Middle income and Electricity production(% of total) in Uruguay?
Keep it short and to the point. -1.17. In the year 1996, what is the difference between the Electricity production(% of total) of Kenya and Electricity production(% of total) of Malta?
Provide a succinct answer. -90.5. In the year 1996, what is the difference between the Electricity production(% of total) of Kenya and Electricity production(% of total) of Uruguay?
Keep it short and to the point. -3.41. In the year 1996, what is the difference between the Electricity production(% of total) of Malta and Electricity production(% of total) of Uruguay?
Provide a succinct answer. 87.09. In the year 1997, what is the difference between the Electricity production(% of total) in Middle income and Electricity production(% of total) in Kenya?
Offer a terse response. -4.84. In the year 1997, what is the difference between the Electricity production(% of total) of Middle income and Electricity production(% of total) of Malta?
Provide a succinct answer. -88.28. In the year 1997, what is the difference between the Electricity production(% of total) in Middle income and Electricity production(% of total) in Uruguay?
Keep it short and to the point. 2.9. In the year 1997, what is the difference between the Electricity production(% of total) in Kenya and Electricity production(% of total) in Malta?
Offer a very short reply. -83.43. In the year 1997, what is the difference between the Electricity production(% of total) of Kenya and Electricity production(% of total) of Uruguay?
Give a very brief answer. 7.74. In the year 1997, what is the difference between the Electricity production(% of total) of Malta and Electricity production(% of total) of Uruguay?
Your response must be concise. 91.17. In the year 1998, what is the difference between the Electricity production(% of total) in Middle income and Electricity production(% of total) in Kenya?
Ensure brevity in your answer.  -6.3. In the year 1998, what is the difference between the Electricity production(% of total) of Middle income and Electricity production(% of total) of Malta?
Your answer should be very brief. -88.29. In the year 1998, what is the difference between the Electricity production(% of total) of Middle income and Electricity production(% of total) of Uruguay?
Keep it short and to the point. 7.83. In the year 1998, what is the difference between the Electricity production(% of total) in Kenya and Electricity production(% of total) in Malta?
Keep it short and to the point. -81.98. In the year 1998, what is the difference between the Electricity production(% of total) in Kenya and Electricity production(% of total) in Uruguay?
Make the answer very short. 14.14. In the year 1998, what is the difference between the Electricity production(% of total) in Malta and Electricity production(% of total) in Uruguay?
Give a very brief answer. 96.12. In the year 1999, what is the difference between the Electricity production(% of total) of Middle income and Electricity production(% of total) of Kenya?
Ensure brevity in your answer.  -22.65. In the year 1999, what is the difference between the Electricity production(% of total) in Middle income and Electricity production(% of total) in Malta?
Your answer should be very brief. -89.03. In the year 1999, what is the difference between the Electricity production(% of total) of Middle income and Electricity production(% of total) of Uruguay?
Offer a very short reply. -11.92. In the year 1999, what is the difference between the Electricity production(% of total) in Kenya and Electricity production(% of total) in Malta?
Your response must be concise. -66.38. In the year 1999, what is the difference between the Electricity production(% of total) of Kenya and Electricity production(% of total) of Uruguay?
Keep it short and to the point. 10.73. In the year 1999, what is the difference between the Electricity production(% of total) in Malta and Electricity production(% of total) in Uruguay?
Offer a very short reply. 77.11. In the year 2000, what is the difference between the Electricity production(% of total) in Middle income and Electricity production(% of total) in Kenya?
Ensure brevity in your answer.  -39.96. In the year 2000, what is the difference between the Electricity production(% of total) in Middle income and Electricity production(% of total) in Malta?
Offer a very short reply. -89.31. In the year 2000, what is the difference between the Electricity production(% of total) of Middle income and Electricity production(% of total) of Uruguay?
Your response must be concise. 4.07. In the year 2000, what is the difference between the Electricity production(% of total) in Kenya and Electricity production(% of total) in Malta?
Ensure brevity in your answer.  -49.36. In the year 2000, what is the difference between the Electricity production(% of total) in Kenya and Electricity production(% of total) in Uruguay?
Provide a succinct answer. 44.03. In the year 2000, what is the difference between the Electricity production(% of total) in Malta and Electricity production(% of total) in Uruguay?
Keep it short and to the point. 93.38. What is the ratio of the Electricity production(% of total) in Middle income in 1993 to that in 1994?
Offer a very short reply. 1.07. What is the ratio of the Electricity production(% of total) of Kenya in 1993 to that in 1994?
Provide a succinct answer. 0.63. What is the ratio of the Electricity production(% of total) in Malta in 1993 to that in 1994?
Your answer should be very brief. 0.78. What is the ratio of the Electricity production(% of total) of Uruguay in 1993 to that in 1994?
Your answer should be very brief. 6.44. What is the ratio of the Electricity production(% of total) of Middle income in 1993 to that in 1995?
Your answer should be compact. 1.09. What is the ratio of the Electricity production(% of total) of Kenya in 1993 to that in 1995?
Give a very brief answer. 0.36. What is the ratio of the Electricity production(% of total) in Malta in 1993 to that in 1995?
Keep it short and to the point. 0.64. What is the ratio of the Electricity production(% of total) in Uruguay in 1993 to that in 1995?
Your response must be concise. 1.2. What is the ratio of the Electricity production(% of total) of Middle income in 1993 to that in 1996?
Offer a terse response. 1.13. What is the ratio of the Electricity production(% of total) in Kenya in 1993 to that in 1996?
Your response must be concise. 0.38. What is the ratio of the Electricity production(% of total) in Uruguay in 1993 to that in 1996?
Provide a short and direct response. 0.6. What is the ratio of the Electricity production(% of total) of Middle income in 1993 to that in 1997?
Your response must be concise. 1.13. What is the ratio of the Electricity production(% of total) of Kenya in 1993 to that in 1997?
Your answer should be very brief. 0.22. What is the ratio of the Electricity production(% of total) of Malta in 1993 to that in 1997?
Offer a terse response. 0.6. What is the ratio of the Electricity production(% of total) in Uruguay in 1993 to that in 1997?
Your answer should be compact. 0.88. What is the ratio of the Electricity production(% of total) in Middle income in 1993 to that in 1998?
Give a very brief answer. 1.13. What is the ratio of the Electricity production(% of total) of Kenya in 1993 to that in 1998?
Provide a succinct answer. 0.2. What is the ratio of the Electricity production(% of total) of Uruguay in 1993 to that in 1998?
Give a very brief answer. 2. What is the ratio of the Electricity production(% of total) of Middle income in 1993 to that in 1999?
Offer a very short reply. 1.21. What is the ratio of the Electricity production(% of total) of Kenya in 1993 to that in 1999?
Offer a very short reply. 0.11. What is the ratio of the Electricity production(% of total) in Malta in 1993 to that in 1999?
Ensure brevity in your answer.  0.6. What is the ratio of the Electricity production(% of total) of Uruguay in 1993 to that in 1999?
Offer a terse response. 0.34. What is the ratio of the Electricity production(% of total) in Middle income in 1993 to that in 2000?
Ensure brevity in your answer.  1.24. What is the ratio of the Electricity production(% of total) of Kenya in 1993 to that in 2000?
Provide a succinct answer. 0.07. What is the ratio of the Electricity production(% of total) of Malta in 1993 to that in 2000?
Your response must be concise. 0.6. What is the ratio of the Electricity production(% of total) in Uruguay in 1993 to that in 2000?
Make the answer very short. 1.17. What is the ratio of the Electricity production(% of total) of Middle income in 1994 to that in 1995?
Your answer should be very brief. 1.02. What is the ratio of the Electricity production(% of total) in Kenya in 1994 to that in 1995?
Keep it short and to the point. 0.56. What is the ratio of the Electricity production(% of total) of Malta in 1994 to that in 1995?
Make the answer very short. 0.81. What is the ratio of the Electricity production(% of total) in Uruguay in 1994 to that in 1995?
Keep it short and to the point. 0.19. What is the ratio of the Electricity production(% of total) of Middle income in 1994 to that in 1996?
Offer a very short reply. 1.05. What is the ratio of the Electricity production(% of total) of Kenya in 1994 to that in 1996?
Make the answer very short. 0.6. What is the ratio of the Electricity production(% of total) in Malta in 1994 to that in 1996?
Make the answer very short. 0.77. What is the ratio of the Electricity production(% of total) of Uruguay in 1994 to that in 1996?
Ensure brevity in your answer.  0.09. What is the ratio of the Electricity production(% of total) in Middle income in 1994 to that in 1997?
Offer a terse response. 1.05. What is the ratio of the Electricity production(% of total) in Kenya in 1994 to that in 1997?
Your answer should be compact. 0.35. What is the ratio of the Electricity production(% of total) of Malta in 1994 to that in 1997?
Offer a very short reply. 0.77. What is the ratio of the Electricity production(% of total) in Uruguay in 1994 to that in 1997?
Your response must be concise. 0.14. What is the ratio of the Electricity production(% of total) in Middle income in 1994 to that in 1998?
Make the answer very short. 1.06. What is the ratio of the Electricity production(% of total) of Kenya in 1994 to that in 1998?
Offer a very short reply. 0.32. What is the ratio of the Electricity production(% of total) of Malta in 1994 to that in 1998?
Offer a very short reply. 0.77. What is the ratio of the Electricity production(% of total) in Uruguay in 1994 to that in 1998?
Your response must be concise. 0.31. What is the ratio of the Electricity production(% of total) in Middle income in 1994 to that in 1999?
Ensure brevity in your answer.  1.13. What is the ratio of the Electricity production(% of total) in Kenya in 1994 to that in 1999?
Your answer should be very brief. 0.17. What is the ratio of the Electricity production(% of total) in Malta in 1994 to that in 1999?
Make the answer very short. 0.77. What is the ratio of the Electricity production(% of total) in Uruguay in 1994 to that in 1999?
Provide a short and direct response. 0.05. What is the ratio of the Electricity production(% of total) in Middle income in 1994 to that in 2000?
Provide a short and direct response. 1.16. What is the ratio of the Electricity production(% of total) of Kenya in 1994 to that in 2000?
Your response must be concise. 0.11. What is the ratio of the Electricity production(% of total) of Malta in 1994 to that in 2000?
Offer a terse response. 0.77. What is the ratio of the Electricity production(% of total) of Uruguay in 1994 to that in 2000?
Provide a short and direct response. 0.18. What is the ratio of the Electricity production(% of total) in Middle income in 1995 to that in 1996?
Your response must be concise. 1.04. What is the ratio of the Electricity production(% of total) of Kenya in 1995 to that in 1996?
Your answer should be compact. 1.07. What is the ratio of the Electricity production(% of total) in Malta in 1995 to that in 1996?
Keep it short and to the point. 0.94. What is the ratio of the Electricity production(% of total) of Uruguay in 1995 to that in 1996?
Keep it short and to the point. 0.5. What is the ratio of the Electricity production(% of total) of Middle income in 1995 to that in 1997?
Your answer should be very brief. 1.04. What is the ratio of the Electricity production(% of total) in Kenya in 1995 to that in 1997?
Provide a short and direct response. 0.61. What is the ratio of the Electricity production(% of total) in Malta in 1995 to that in 1997?
Ensure brevity in your answer.  0.94. What is the ratio of the Electricity production(% of total) of Uruguay in 1995 to that in 1997?
Your answer should be very brief. 0.73. What is the ratio of the Electricity production(% of total) of Middle income in 1995 to that in 1998?
Your response must be concise. 1.04. What is the ratio of the Electricity production(% of total) of Kenya in 1995 to that in 1998?
Your answer should be very brief. 0.56. What is the ratio of the Electricity production(% of total) of Malta in 1995 to that in 1998?
Offer a terse response. 0.94. What is the ratio of the Electricity production(% of total) of Uruguay in 1995 to that in 1998?
Your response must be concise. 1.66. What is the ratio of the Electricity production(% of total) of Middle income in 1995 to that in 1999?
Offer a very short reply. 1.11. What is the ratio of the Electricity production(% of total) of Kenya in 1995 to that in 1999?
Your answer should be very brief. 0.3. What is the ratio of the Electricity production(% of total) in Malta in 1995 to that in 1999?
Your response must be concise. 0.94. What is the ratio of the Electricity production(% of total) in Uruguay in 1995 to that in 1999?
Give a very brief answer. 0.28. What is the ratio of the Electricity production(% of total) of Middle income in 1995 to that in 2000?
Provide a succinct answer. 1.14. What is the ratio of the Electricity production(% of total) of Kenya in 1995 to that in 2000?
Provide a succinct answer. 0.2. What is the ratio of the Electricity production(% of total) of Malta in 1995 to that in 2000?
Keep it short and to the point. 0.94. What is the ratio of the Electricity production(% of total) of Uruguay in 1995 to that in 2000?
Make the answer very short. 0.98. What is the ratio of the Electricity production(% of total) in Middle income in 1996 to that in 1997?
Offer a terse response. 1. What is the ratio of the Electricity production(% of total) of Kenya in 1996 to that in 1997?
Your answer should be very brief. 0.57. What is the ratio of the Electricity production(% of total) in Malta in 1996 to that in 1997?
Provide a short and direct response. 1. What is the ratio of the Electricity production(% of total) in Uruguay in 1996 to that in 1997?
Provide a succinct answer. 1.46. What is the ratio of the Electricity production(% of total) of Kenya in 1996 to that in 1998?
Give a very brief answer. 0.53. What is the ratio of the Electricity production(% of total) of Uruguay in 1996 to that in 1998?
Provide a short and direct response. 3.33. What is the ratio of the Electricity production(% of total) of Middle income in 1996 to that in 1999?
Ensure brevity in your answer.  1.07. What is the ratio of the Electricity production(% of total) in Kenya in 1996 to that in 1999?
Ensure brevity in your answer.  0.28. What is the ratio of the Electricity production(% of total) in Malta in 1996 to that in 1999?
Ensure brevity in your answer.  1. What is the ratio of the Electricity production(% of total) in Uruguay in 1996 to that in 1999?
Your answer should be compact. 0.56. What is the ratio of the Electricity production(% of total) of Middle income in 1996 to that in 2000?
Offer a terse response. 1.1. What is the ratio of the Electricity production(% of total) in Kenya in 1996 to that in 2000?
Offer a terse response. 0.19. What is the ratio of the Electricity production(% of total) of Malta in 1996 to that in 2000?
Keep it short and to the point. 1. What is the ratio of the Electricity production(% of total) in Uruguay in 1996 to that in 2000?
Offer a very short reply. 1.95. What is the ratio of the Electricity production(% of total) in Middle income in 1997 to that in 1998?
Ensure brevity in your answer.  1. What is the ratio of the Electricity production(% of total) in Kenya in 1997 to that in 1998?
Your answer should be very brief. 0.92. What is the ratio of the Electricity production(% of total) in Uruguay in 1997 to that in 1998?
Provide a short and direct response. 2.28. What is the ratio of the Electricity production(% of total) of Middle income in 1997 to that in 1999?
Your response must be concise. 1.07. What is the ratio of the Electricity production(% of total) in Kenya in 1997 to that in 1999?
Offer a very short reply. 0.49. What is the ratio of the Electricity production(% of total) of Malta in 1997 to that in 1999?
Offer a terse response. 1. What is the ratio of the Electricity production(% of total) of Uruguay in 1997 to that in 1999?
Offer a very short reply. 0.39. What is the ratio of the Electricity production(% of total) of Middle income in 1997 to that in 2000?
Offer a terse response. 1.1. What is the ratio of the Electricity production(% of total) of Kenya in 1997 to that in 2000?
Your answer should be compact. 0.33. What is the ratio of the Electricity production(% of total) in Uruguay in 1997 to that in 2000?
Offer a terse response. 1.33. What is the ratio of the Electricity production(% of total) in Middle income in 1998 to that in 1999?
Offer a very short reply. 1.07. What is the ratio of the Electricity production(% of total) in Kenya in 1998 to that in 1999?
Give a very brief answer. 0.54. What is the ratio of the Electricity production(% of total) in Uruguay in 1998 to that in 1999?
Keep it short and to the point. 0.17. What is the ratio of the Electricity production(% of total) in Middle income in 1998 to that in 2000?
Your answer should be compact. 1.1. What is the ratio of the Electricity production(% of total) in Kenya in 1998 to that in 2000?
Your answer should be very brief. 0.36. What is the ratio of the Electricity production(% of total) of Malta in 1998 to that in 2000?
Keep it short and to the point. 1. What is the ratio of the Electricity production(% of total) in Uruguay in 1998 to that in 2000?
Offer a very short reply. 0.59. What is the ratio of the Electricity production(% of total) of Middle income in 1999 to that in 2000?
Offer a terse response. 1.03. What is the ratio of the Electricity production(% of total) of Kenya in 1999 to that in 2000?
Offer a very short reply. 0.66. What is the ratio of the Electricity production(% of total) in Malta in 1999 to that in 2000?
Provide a succinct answer. 1. What is the ratio of the Electricity production(% of total) in Uruguay in 1999 to that in 2000?
Your answer should be compact. 3.46. What is the difference between the highest and the second highest Electricity production(% of total) of Middle income?
Your answer should be very brief. 0.88. What is the difference between the highest and the second highest Electricity production(% of total) of Kenya?
Offer a terse response. 17.02. What is the difference between the highest and the second highest Electricity production(% of total) in Uruguay?
Your answer should be very brief. 9.99. What is the difference between the highest and the lowest Electricity production(% of total) of Middle income?
Provide a succinct answer. 2.56. What is the difference between the highest and the lowest Electricity production(% of total) of Kenya?
Your answer should be compact. 47.02. What is the difference between the highest and the lowest Electricity production(% of total) of Uruguay?
Offer a terse response. 21.69. 